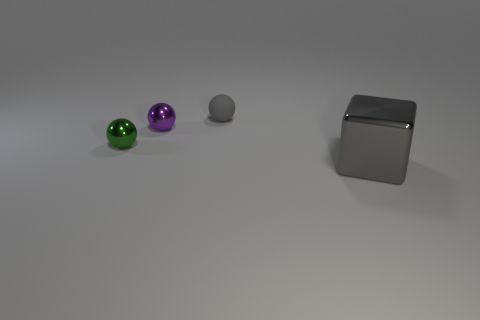Subtract all small purple metallic spheres. How many spheres are left? 2 Add 4 shiny cubes. How many objects exist? 8 Subtract all cubes. How many objects are left? 3 Add 3 green shiny things. How many green shiny things are left? 4 Add 2 big gray metal objects. How many big gray metal objects exist? 3 Subtract 0 brown cubes. How many objects are left? 4 Subtract all tiny cyan rubber things. Subtract all small gray things. How many objects are left? 3 